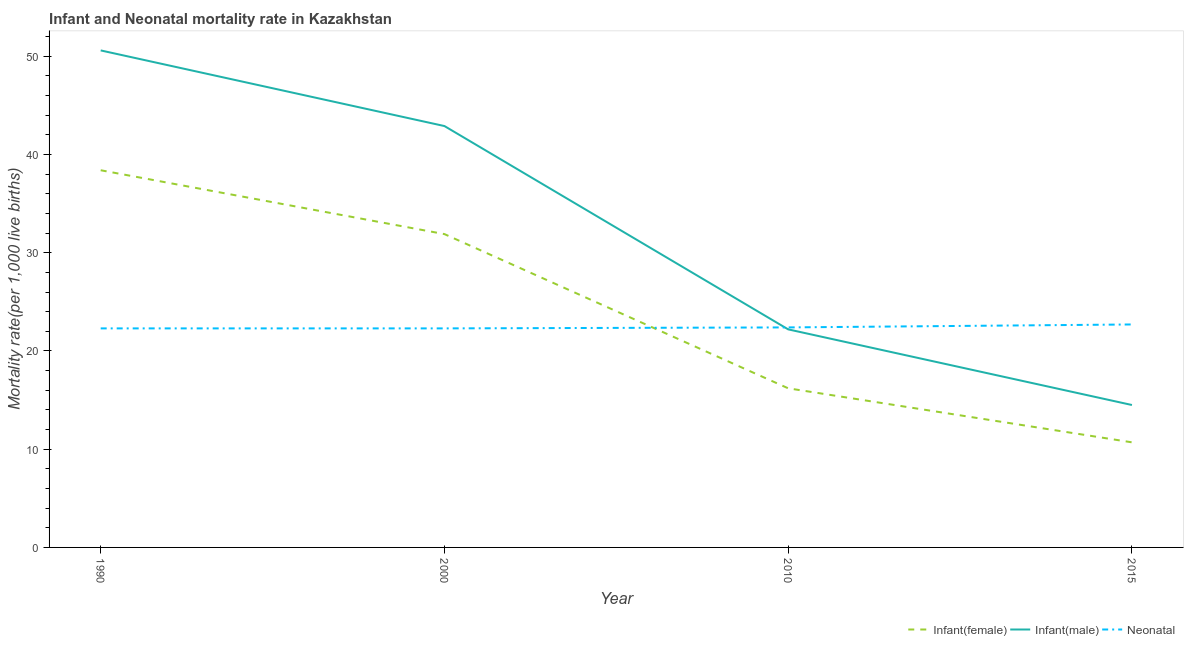Does the line corresponding to infant mortality rate(male) intersect with the line corresponding to neonatal mortality rate?
Provide a short and direct response. Yes. What is the infant mortality rate(female) in 2010?
Ensure brevity in your answer.  16.2. Across all years, what is the maximum neonatal mortality rate?
Offer a very short reply. 22.7. In which year was the neonatal mortality rate maximum?
Offer a terse response. 2015. In which year was the infant mortality rate(male) minimum?
Make the answer very short. 2015. What is the total infant mortality rate(male) in the graph?
Make the answer very short. 130.2. What is the difference between the infant mortality rate(male) in 1990 and that in 2000?
Provide a short and direct response. 7.7. What is the difference between the infant mortality rate(female) in 2010 and the neonatal mortality rate in 1990?
Ensure brevity in your answer.  -6.1. What is the average infant mortality rate(male) per year?
Keep it short and to the point. 32.55. In the year 2010, what is the difference between the neonatal mortality rate and infant mortality rate(female)?
Offer a terse response. 6.2. What is the ratio of the infant mortality rate(male) in 1990 to that in 2015?
Ensure brevity in your answer.  3.49. Is the infant mortality rate(female) in 2010 less than that in 2015?
Make the answer very short. No. Is the difference between the neonatal mortality rate in 2000 and 2015 greater than the difference between the infant mortality rate(male) in 2000 and 2015?
Your answer should be compact. No. What is the difference between the highest and the second highest infant mortality rate(female)?
Provide a short and direct response. 6.5. What is the difference between the highest and the lowest neonatal mortality rate?
Provide a succinct answer. 0.4. Is the sum of the infant mortality rate(male) in 1990 and 2000 greater than the maximum neonatal mortality rate across all years?
Offer a very short reply. Yes. Is it the case that in every year, the sum of the infant mortality rate(female) and infant mortality rate(male) is greater than the neonatal mortality rate?
Provide a succinct answer. Yes. Is the infant mortality rate(male) strictly greater than the infant mortality rate(female) over the years?
Ensure brevity in your answer.  Yes. Is the infant mortality rate(female) strictly less than the infant mortality rate(male) over the years?
Your answer should be compact. Yes. How many lines are there?
Ensure brevity in your answer.  3. How many years are there in the graph?
Ensure brevity in your answer.  4. What is the difference between two consecutive major ticks on the Y-axis?
Give a very brief answer. 10. How are the legend labels stacked?
Your response must be concise. Horizontal. What is the title of the graph?
Provide a succinct answer. Infant and Neonatal mortality rate in Kazakhstan. What is the label or title of the X-axis?
Make the answer very short. Year. What is the label or title of the Y-axis?
Offer a very short reply. Mortality rate(per 1,0 live births). What is the Mortality rate(per 1,000 live births) in Infant(female) in 1990?
Your answer should be compact. 38.4. What is the Mortality rate(per 1,000 live births) in Infant(male) in 1990?
Ensure brevity in your answer.  50.6. What is the Mortality rate(per 1,000 live births) in Neonatal  in 1990?
Your answer should be compact. 22.3. What is the Mortality rate(per 1,000 live births) of Infant(female) in 2000?
Offer a terse response. 31.9. What is the Mortality rate(per 1,000 live births) of Infant(male) in 2000?
Your answer should be compact. 42.9. What is the Mortality rate(per 1,000 live births) in Neonatal  in 2000?
Provide a succinct answer. 22.3. What is the Mortality rate(per 1,000 live births) in Neonatal  in 2010?
Keep it short and to the point. 22.4. What is the Mortality rate(per 1,000 live births) in Neonatal  in 2015?
Keep it short and to the point. 22.7. Across all years, what is the maximum Mortality rate(per 1,000 live births) of Infant(female)?
Offer a very short reply. 38.4. Across all years, what is the maximum Mortality rate(per 1,000 live births) of Infant(male)?
Your response must be concise. 50.6. Across all years, what is the maximum Mortality rate(per 1,000 live births) in Neonatal ?
Your answer should be very brief. 22.7. Across all years, what is the minimum Mortality rate(per 1,000 live births) of Infant(female)?
Your answer should be compact. 10.7. Across all years, what is the minimum Mortality rate(per 1,000 live births) of Neonatal ?
Provide a short and direct response. 22.3. What is the total Mortality rate(per 1,000 live births) of Infant(female) in the graph?
Ensure brevity in your answer.  97.2. What is the total Mortality rate(per 1,000 live births) of Infant(male) in the graph?
Offer a terse response. 130.2. What is the total Mortality rate(per 1,000 live births) in Neonatal  in the graph?
Offer a very short reply. 89.7. What is the difference between the Mortality rate(per 1,000 live births) in Infant(male) in 1990 and that in 2000?
Provide a succinct answer. 7.7. What is the difference between the Mortality rate(per 1,000 live births) in Neonatal  in 1990 and that in 2000?
Offer a terse response. 0. What is the difference between the Mortality rate(per 1,000 live births) in Infant(female) in 1990 and that in 2010?
Give a very brief answer. 22.2. What is the difference between the Mortality rate(per 1,000 live births) of Infant(male) in 1990 and that in 2010?
Offer a terse response. 28.4. What is the difference between the Mortality rate(per 1,000 live births) of Infant(female) in 1990 and that in 2015?
Keep it short and to the point. 27.7. What is the difference between the Mortality rate(per 1,000 live births) in Infant(male) in 1990 and that in 2015?
Your answer should be compact. 36.1. What is the difference between the Mortality rate(per 1,000 live births) in Neonatal  in 1990 and that in 2015?
Offer a very short reply. -0.4. What is the difference between the Mortality rate(per 1,000 live births) in Infant(female) in 2000 and that in 2010?
Provide a short and direct response. 15.7. What is the difference between the Mortality rate(per 1,000 live births) of Infant(male) in 2000 and that in 2010?
Give a very brief answer. 20.7. What is the difference between the Mortality rate(per 1,000 live births) of Neonatal  in 2000 and that in 2010?
Offer a very short reply. -0.1. What is the difference between the Mortality rate(per 1,000 live births) in Infant(female) in 2000 and that in 2015?
Make the answer very short. 21.2. What is the difference between the Mortality rate(per 1,000 live births) of Infant(male) in 2000 and that in 2015?
Keep it short and to the point. 28.4. What is the difference between the Mortality rate(per 1,000 live births) in Neonatal  in 2000 and that in 2015?
Give a very brief answer. -0.4. What is the difference between the Mortality rate(per 1,000 live births) of Infant(female) in 2010 and that in 2015?
Keep it short and to the point. 5.5. What is the difference between the Mortality rate(per 1,000 live births) in Infant(male) in 2010 and that in 2015?
Your answer should be very brief. 7.7. What is the difference between the Mortality rate(per 1,000 live births) of Infant(female) in 1990 and the Mortality rate(per 1,000 live births) of Infant(male) in 2000?
Offer a terse response. -4.5. What is the difference between the Mortality rate(per 1,000 live births) of Infant(female) in 1990 and the Mortality rate(per 1,000 live births) of Neonatal  in 2000?
Your answer should be very brief. 16.1. What is the difference between the Mortality rate(per 1,000 live births) of Infant(male) in 1990 and the Mortality rate(per 1,000 live births) of Neonatal  in 2000?
Offer a very short reply. 28.3. What is the difference between the Mortality rate(per 1,000 live births) in Infant(female) in 1990 and the Mortality rate(per 1,000 live births) in Infant(male) in 2010?
Provide a succinct answer. 16.2. What is the difference between the Mortality rate(per 1,000 live births) in Infant(female) in 1990 and the Mortality rate(per 1,000 live births) in Neonatal  in 2010?
Provide a succinct answer. 16. What is the difference between the Mortality rate(per 1,000 live births) of Infant(male) in 1990 and the Mortality rate(per 1,000 live births) of Neonatal  in 2010?
Give a very brief answer. 28.2. What is the difference between the Mortality rate(per 1,000 live births) in Infant(female) in 1990 and the Mortality rate(per 1,000 live births) in Infant(male) in 2015?
Your response must be concise. 23.9. What is the difference between the Mortality rate(per 1,000 live births) of Infant(female) in 1990 and the Mortality rate(per 1,000 live births) of Neonatal  in 2015?
Provide a succinct answer. 15.7. What is the difference between the Mortality rate(per 1,000 live births) of Infant(male) in 1990 and the Mortality rate(per 1,000 live births) of Neonatal  in 2015?
Keep it short and to the point. 27.9. What is the difference between the Mortality rate(per 1,000 live births) of Infant(male) in 2000 and the Mortality rate(per 1,000 live births) of Neonatal  in 2010?
Ensure brevity in your answer.  20.5. What is the difference between the Mortality rate(per 1,000 live births) of Infant(female) in 2000 and the Mortality rate(per 1,000 live births) of Infant(male) in 2015?
Ensure brevity in your answer.  17.4. What is the difference between the Mortality rate(per 1,000 live births) of Infant(male) in 2000 and the Mortality rate(per 1,000 live births) of Neonatal  in 2015?
Offer a terse response. 20.2. What is the difference between the Mortality rate(per 1,000 live births) of Infant(female) in 2010 and the Mortality rate(per 1,000 live births) of Infant(male) in 2015?
Offer a very short reply. 1.7. What is the difference between the Mortality rate(per 1,000 live births) in Infant(female) in 2010 and the Mortality rate(per 1,000 live births) in Neonatal  in 2015?
Keep it short and to the point. -6.5. What is the average Mortality rate(per 1,000 live births) of Infant(female) per year?
Your answer should be compact. 24.3. What is the average Mortality rate(per 1,000 live births) of Infant(male) per year?
Provide a short and direct response. 32.55. What is the average Mortality rate(per 1,000 live births) in Neonatal  per year?
Provide a succinct answer. 22.43. In the year 1990, what is the difference between the Mortality rate(per 1,000 live births) in Infant(female) and Mortality rate(per 1,000 live births) in Infant(male)?
Provide a succinct answer. -12.2. In the year 1990, what is the difference between the Mortality rate(per 1,000 live births) of Infant(female) and Mortality rate(per 1,000 live births) of Neonatal ?
Your answer should be very brief. 16.1. In the year 1990, what is the difference between the Mortality rate(per 1,000 live births) in Infant(male) and Mortality rate(per 1,000 live births) in Neonatal ?
Your response must be concise. 28.3. In the year 2000, what is the difference between the Mortality rate(per 1,000 live births) of Infant(female) and Mortality rate(per 1,000 live births) of Infant(male)?
Your answer should be compact. -11. In the year 2000, what is the difference between the Mortality rate(per 1,000 live births) in Infant(male) and Mortality rate(per 1,000 live births) in Neonatal ?
Keep it short and to the point. 20.6. In the year 2010, what is the difference between the Mortality rate(per 1,000 live births) in Infant(female) and Mortality rate(per 1,000 live births) in Infant(male)?
Your answer should be compact. -6. In the year 2010, what is the difference between the Mortality rate(per 1,000 live births) of Infant(female) and Mortality rate(per 1,000 live births) of Neonatal ?
Your response must be concise. -6.2. In the year 2010, what is the difference between the Mortality rate(per 1,000 live births) in Infant(male) and Mortality rate(per 1,000 live births) in Neonatal ?
Provide a short and direct response. -0.2. In the year 2015, what is the difference between the Mortality rate(per 1,000 live births) in Infant(female) and Mortality rate(per 1,000 live births) in Infant(male)?
Give a very brief answer. -3.8. In the year 2015, what is the difference between the Mortality rate(per 1,000 live births) in Infant(female) and Mortality rate(per 1,000 live births) in Neonatal ?
Offer a terse response. -12. In the year 2015, what is the difference between the Mortality rate(per 1,000 live births) in Infant(male) and Mortality rate(per 1,000 live births) in Neonatal ?
Your answer should be very brief. -8.2. What is the ratio of the Mortality rate(per 1,000 live births) of Infant(female) in 1990 to that in 2000?
Provide a short and direct response. 1.2. What is the ratio of the Mortality rate(per 1,000 live births) in Infant(male) in 1990 to that in 2000?
Provide a succinct answer. 1.18. What is the ratio of the Mortality rate(per 1,000 live births) in Neonatal  in 1990 to that in 2000?
Ensure brevity in your answer.  1. What is the ratio of the Mortality rate(per 1,000 live births) in Infant(female) in 1990 to that in 2010?
Provide a succinct answer. 2.37. What is the ratio of the Mortality rate(per 1,000 live births) of Infant(male) in 1990 to that in 2010?
Your response must be concise. 2.28. What is the ratio of the Mortality rate(per 1,000 live births) of Infant(female) in 1990 to that in 2015?
Provide a short and direct response. 3.59. What is the ratio of the Mortality rate(per 1,000 live births) of Infant(male) in 1990 to that in 2015?
Your answer should be compact. 3.49. What is the ratio of the Mortality rate(per 1,000 live births) in Neonatal  in 1990 to that in 2015?
Make the answer very short. 0.98. What is the ratio of the Mortality rate(per 1,000 live births) in Infant(female) in 2000 to that in 2010?
Your answer should be very brief. 1.97. What is the ratio of the Mortality rate(per 1,000 live births) in Infant(male) in 2000 to that in 2010?
Offer a very short reply. 1.93. What is the ratio of the Mortality rate(per 1,000 live births) in Infant(female) in 2000 to that in 2015?
Offer a very short reply. 2.98. What is the ratio of the Mortality rate(per 1,000 live births) of Infant(male) in 2000 to that in 2015?
Ensure brevity in your answer.  2.96. What is the ratio of the Mortality rate(per 1,000 live births) of Neonatal  in 2000 to that in 2015?
Your response must be concise. 0.98. What is the ratio of the Mortality rate(per 1,000 live births) of Infant(female) in 2010 to that in 2015?
Provide a succinct answer. 1.51. What is the ratio of the Mortality rate(per 1,000 live births) in Infant(male) in 2010 to that in 2015?
Give a very brief answer. 1.53. What is the difference between the highest and the second highest Mortality rate(per 1,000 live births) in Infant(female)?
Your answer should be very brief. 6.5. What is the difference between the highest and the second highest Mortality rate(per 1,000 live births) in Infant(male)?
Your response must be concise. 7.7. What is the difference between the highest and the second highest Mortality rate(per 1,000 live births) of Neonatal ?
Offer a terse response. 0.3. What is the difference between the highest and the lowest Mortality rate(per 1,000 live births) in Infant(female)?
Ensure brevity in your answer.  27.7. What is the difference between the highest and the lowest Mortality rate(per 1,000 live births) in Infant(male)?
Your answer should be very brief. 36.1. 